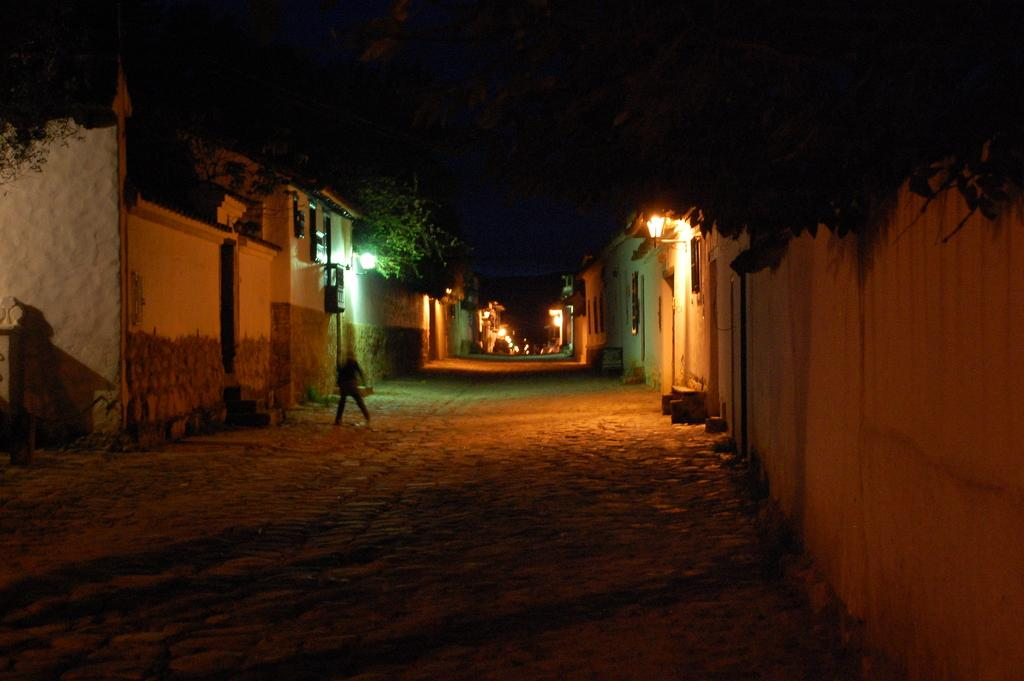What type of structures can be seen in the image? There are houses in the image. What feature is common to the houses in the image? There are windows visible in the image. What can be seen illuminating the houses and surroundings? There are lights in the image. What type of natural elements are present in the image? There are trees in the image. What type of barrier can be seen in the image? There is a wall in the image. What type of tooth is visible in the image? There is no tooth present in the image. What type of border can be seen surrounding the houses in the image? The provided facts do not mention a border surrounding the houses; only a wall is mentioned. 